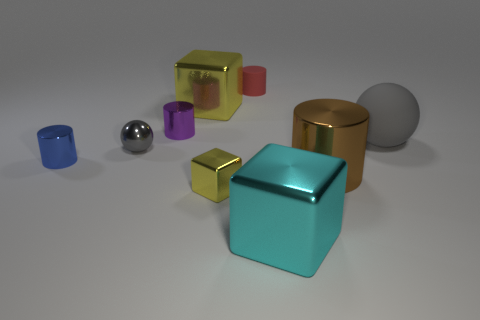What number of big gray matte things are in front of the cylinder in front of the tiny blue cylinder?
Make the answer very short. 0. There is a tiny thing that is in front of the small gray sphere and behind the tiny yellow object; what is its material?
Offer a terse response. Metal. Do the big shiny thing that is on the left side of the small red matte cylinder and the small rubber object have the same shape?
Provide a succinct answer. No. Are there fewer big brown metallic cylinders than red rubber blocks?
Ensure brevity in your answer.  No. How many tiny metallic things are the same color as the large matte object?
Provide a succinct answer. 1. What material is the other ball that is the same color as the metallic ball?
Offer a very short reply. Rubber. Does the small rubber cylinder have the same color as the metal cube that is behind the tiny block?
Give a very brief answer. No. Is the number of large blue matte balls greater than the number of metallic things?
Ensure brevity in your answer.  No. The brown shiny thing that is the same shape as the red rubber thing is what size?
Offer a very short reply. Large. Is the material of the tiny yellow object the same as the gray object that is to the right of the small matte cylinder?
Provide a short and direct response. No. 